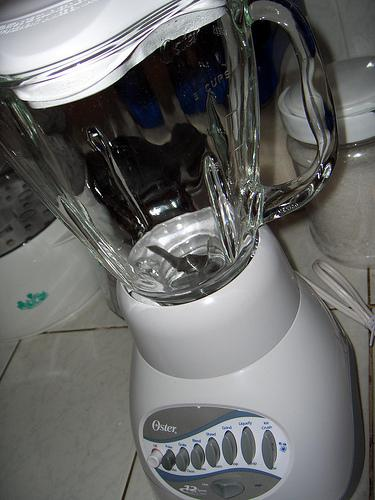Question: what appliance is pictured?
Choices:
A. Microwave.
B. Stove.
C. Toaster.
D. Blender.
Answer with the letter. Answer: D Question: what color is the blender bowl?
Choices:
A. Red.
B. White.
C. Green.
D. Clear.
Answer with the letter. Answer: D Question: what is the blender sitting on?
Choices:
A. Counter.
B. Table.
C. Stove.
D. Microwave.
Answer with the letter. Answer: A 